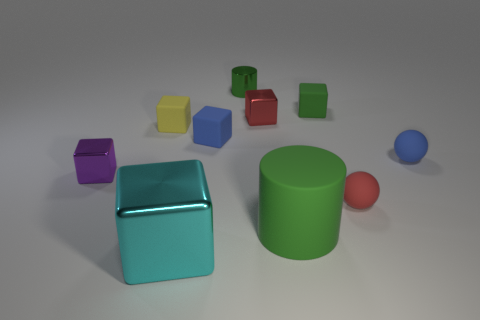What shape is the tiny metal object that is to the right of the small green object on the left side of the big green cylinder?
Ensure brevity in your answer.  Cube. Is there anything else that has the same color as the large block?
Give a very brief answer. No. Does the purple object have the same size as the green thing on the right side of the large green object?
Your response must be concise. Yes. What number of tiny things are blue balls or red things?
Keep it short and to the point. 3. Are there more small purple shiny cubes than matte things?
Provide a succinct answer. No. There is a red thing in front of the blue matte object behind the tiny blue sphere; what number of yellow matte things are behind it?
Provide a succinct answer. 1. The yellow thing is what shape?
Provide a short and direct response. Cube. How many other things are there of the same material as the small red block?
Offer a terse response. 3. Is the purple cube the same size as the red block?
Your answer should be compact. Yes. There is a small rubber object on the left side of the large cyan cube; what shape is it?
Keep it short and to the point. Cube. 